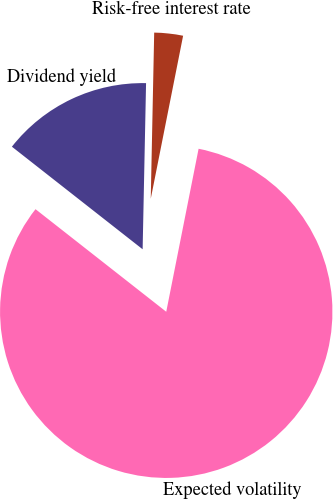Convert chart. <chart><loc_0><loc_0><loc_500><loc_500><pie_chart><fcel>Dividend yield<fcel>Expected volatility<fcel>Risk-free interest rate<nl><fcel>14.74%<fcel>82.47%<fcel>2.79%<nl></chart> 